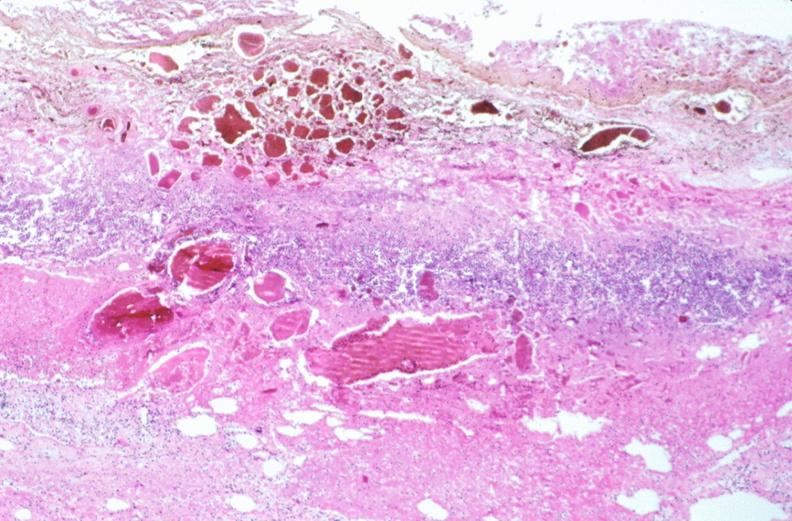where is this from?
Answer the question using a single word or phrase. Gastrointestinal system 